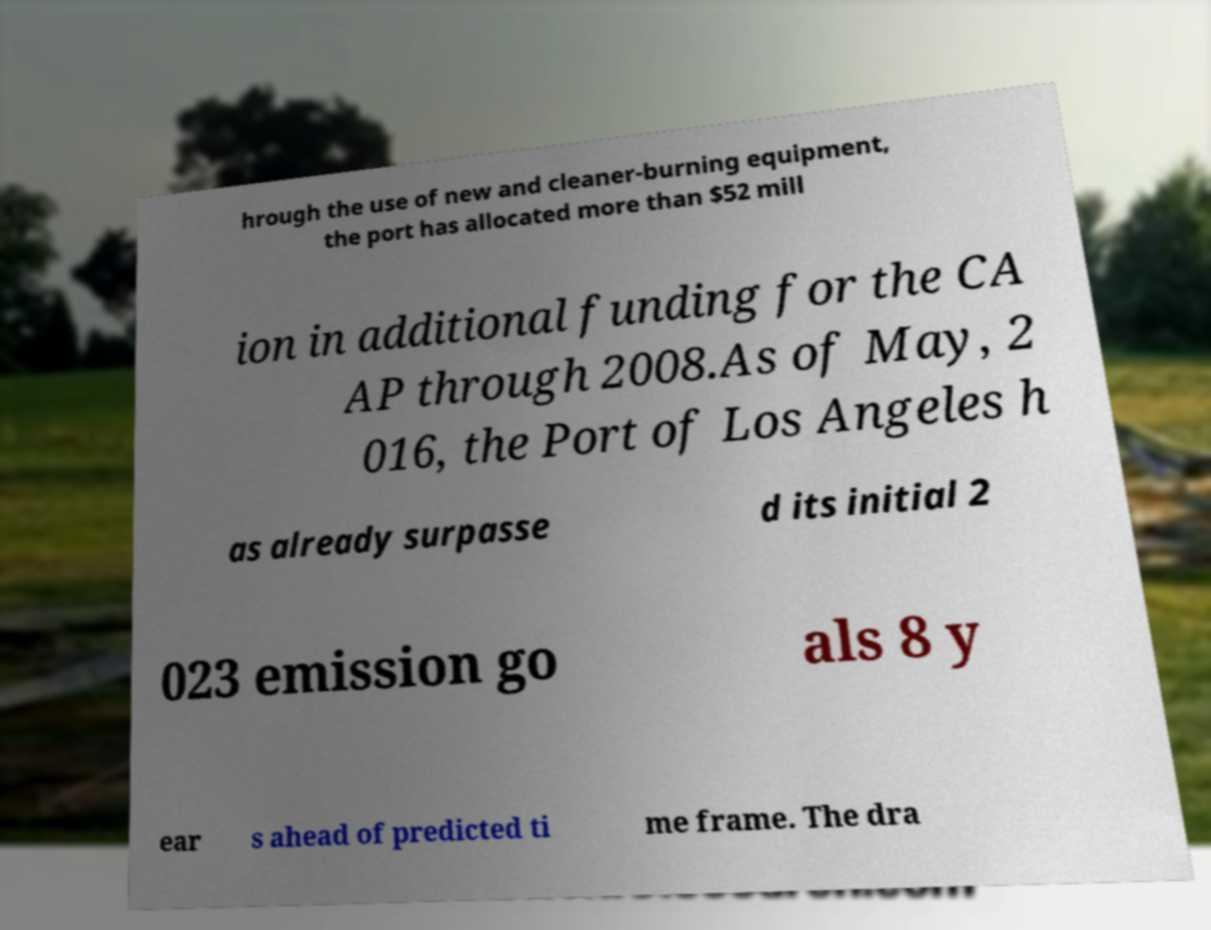Could you extract and type out the text from this image? hrough the use of new and cleaner-burning equipment, the port has allocated more than $52 mill ion in additional funding for the CA AP through 2008.As of May, 2 016, the Port of Los Angeles h as already surpasse d its initial 2 023 emission go als 8 y ear s ahead of predicted ti me frame. The dra 